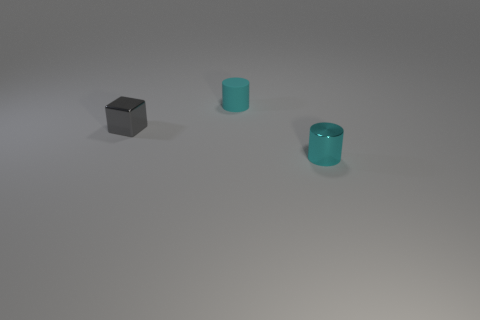Is there any other thing that is the same shape as the gray thing?
Offer a terse response. No. What shape is the metallic thing on the right side of the small rubber cylinder?
Ensure brevity in your answer.  Cylinder. Do the matte thing and the tiny cyan shiny thing have the same shape?
Your answer should be very brief. Yes. Is the number of cylinders that are behind the tiny gray shiny cube the same as the number of large blue blocks?
Keep it short and to the point. No. There is a small gray thing; what shape is it?
Give a very brief answer. Cube. Is there anything else that is the same color as the metallic cylinder?
Your answer should be very brief. Yes. What is the shape of the small metallic object that is left of the thing that is behind the tiny block?
Your answer should be very brief. Cube. Is the size of the matte thing the same as the gray metal object that is on the left side of the shiny cylinder?
Your answer should be very brief. Yes. How many objects are either cyan cylinders left of the metallic cylinder or small cyan rubber cylinders?
Provide a succinct answer. 1. There is a metallic object that is left of the tiny cyan metallic thing; how many cyan cylinders are to the left of it?
Your answer should be compact. 0. 